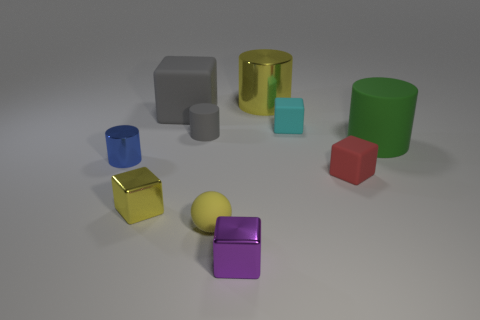What color is the large metallic thing that is the same shape as the green rubber thing?
Offer a terse response. Yellow. Does the purple thing have the same size as the cyan matte thing?
Make the answer very short. Yes. Is the number of big cylinders that are right of the big green matte cylinder the same as the number of large cylinders?
Your response must be concise. No. There is a large matte object on the right side of the red matte thing; is there a green matte cylinder that is behind it?
Keep it short and to the point. No. What size is the rubber cube that is left of the tiny metallic object that is on the right side of the yellow shiny object in front of the yellow metallic cylinder?
Give a very brief answer. Large. What material is the large cylinder behind the small cube behind the blue cylinder?
Provide a short and direct response. Metal. Is there another object that has the same shape as the tiny red object?
Give a very brief answer. Yes. What is the shape of the purple metallic object?
Provide a succinct answer. Cube. What is the large thing left of the small yellow object on the right side of the big rubber thing behind the green object made of?
Provide a succinct answer. Rubber. Is the number of small metallic blocks to the right of the small red matte thing greater than the number of cyan things?
Keep it short and to the point. No. 